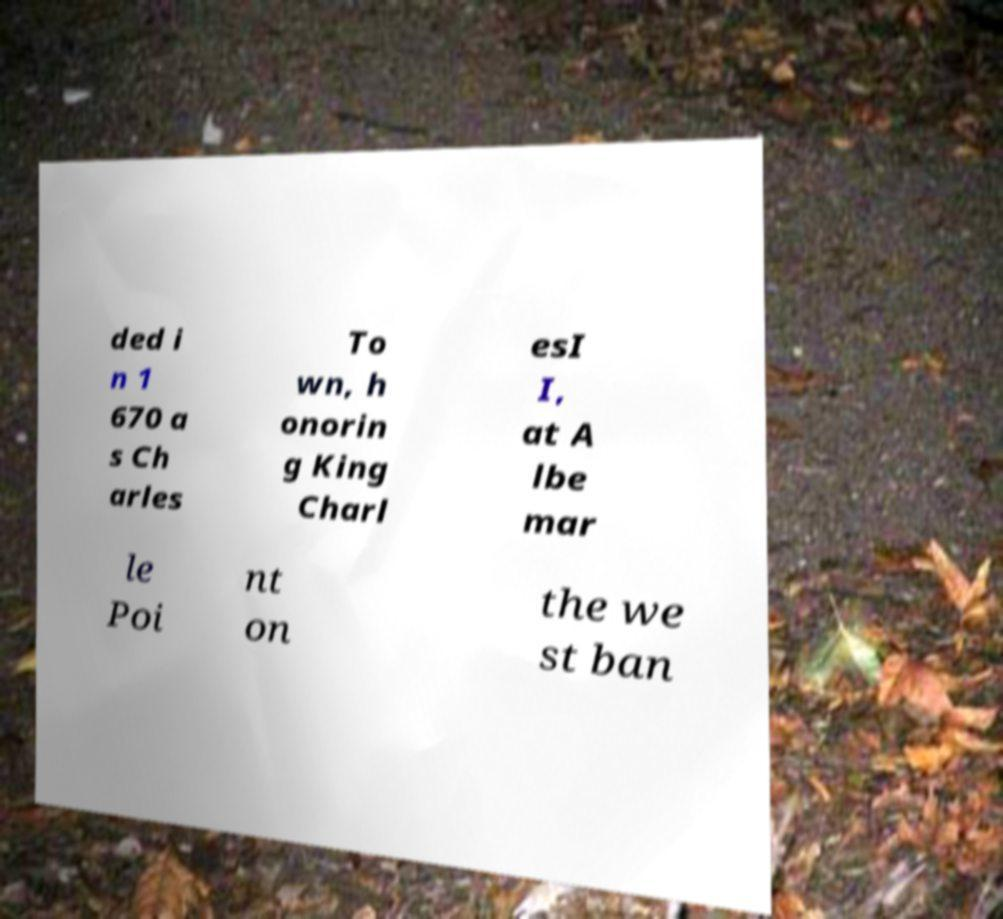Could you extract and type out the text from this image? ded i n 1 670 a s Ch arles To wn, h onorin g King Charl esI I, at A lbe mar le Poi nt on the we st ban 